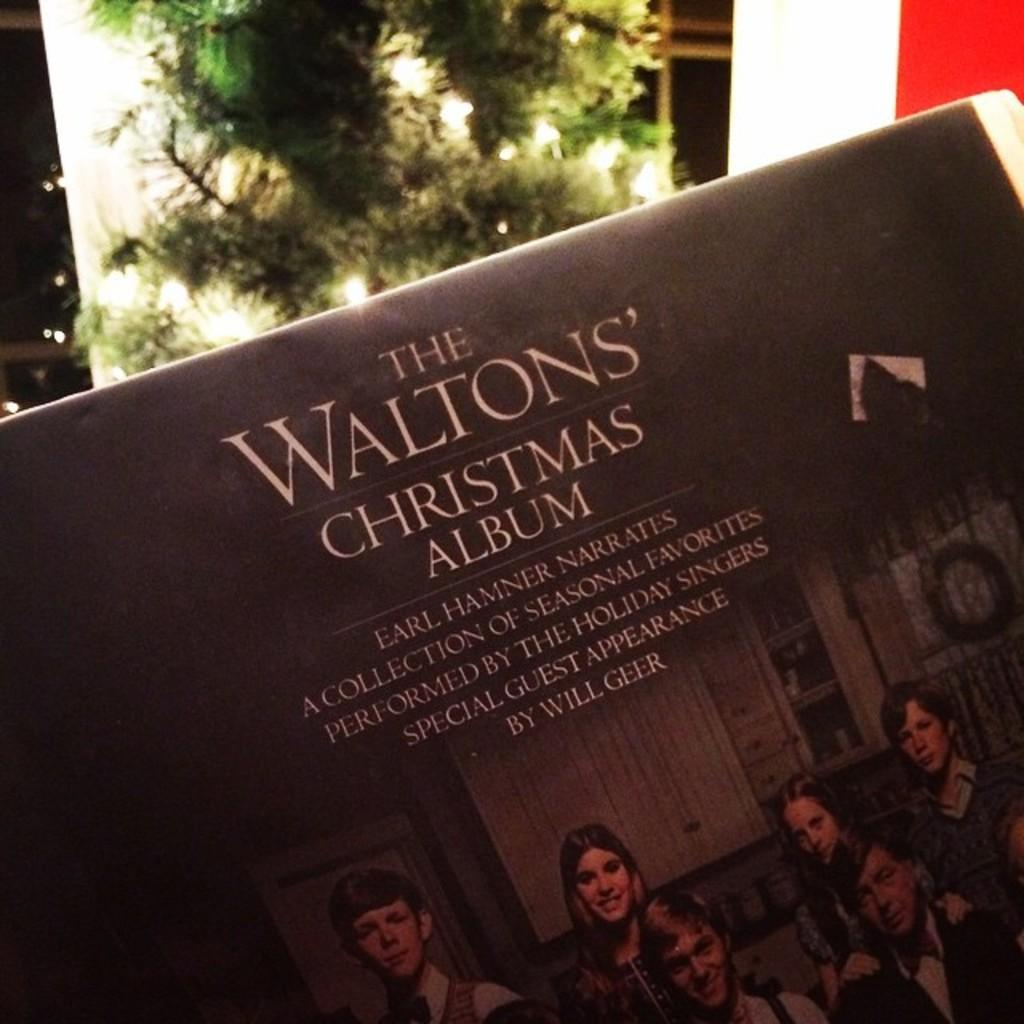What is the main subject of the image? The main subject of the image is a picture of few persons. What is written on the board in the image? There are texts written on a board in the image. What can be seen in the background of the image? There is a plant and other objects in the background of the image. Can you tell me how many buttons are on the sister's shirt in the image? There is no sister or shirt with buttons present in the image. What type of whistle can be heard in the background of the image? There is no whistle present in the image, and therefore no sound can be heard. 